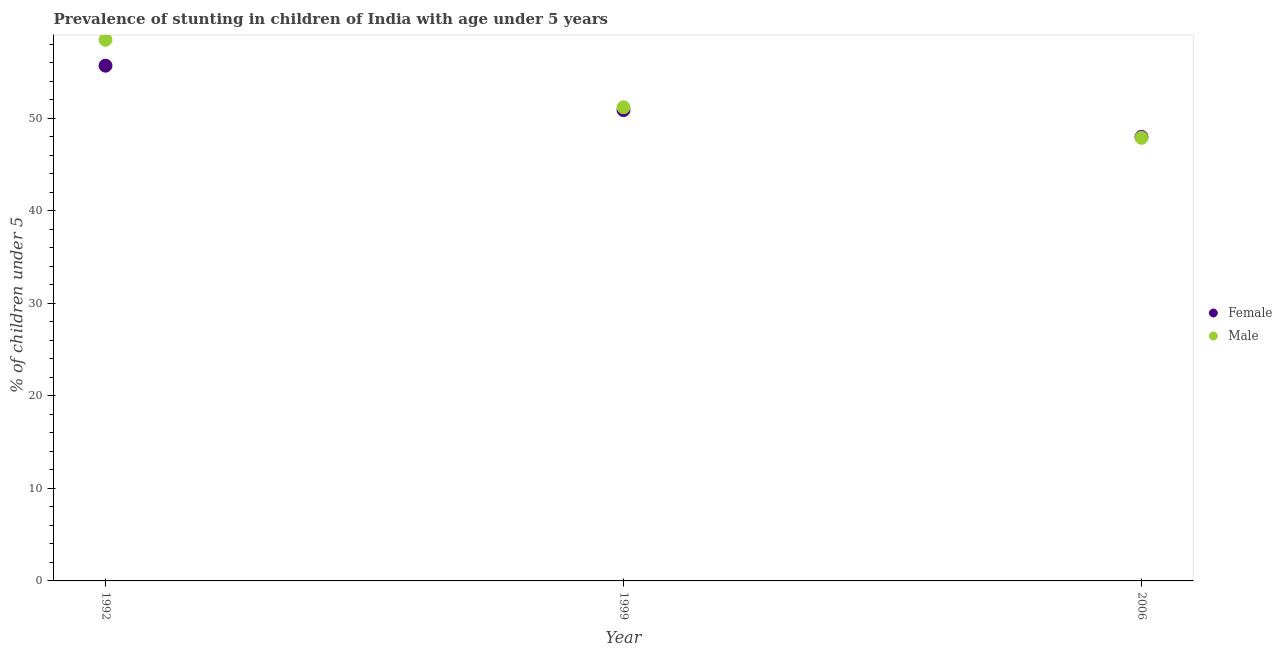Is the number of dotlines equal to the number of legend labels?
Your response must be concise. Yes. What is the percentage of stunted male children in 2006?
Your answer should be compact. 47.9. Across all years, what is the maximum percentage of stunted male children?
Ensure brevity in your answer.  58.5. What is the total percentage of stunted male children in the graph?
Provide a succinct answer. 157.6. What is the difference between the percentage of stunted female children in 1992 and that in 2006?
Your answer should be compact. 7.7. What is the difference between the percentage of stunted male children in 2006 and the percentage of stunted female children in 1999?
Ensure brevity in your answer.  -3. What is the average percentage of stunted male children per year?
Provide a short and direct response. 52.53. In the year 1999, what is the difference between the percentage of stunted female children and percentage of stunted male children?
Your answer should be very brief. -0.3. What is the ratio of the percentage of stunted male children in 1992 to that in 1999?
Ensure brevity in your answer.  1.14. Is the percentage of stunted female children in 1999 less than that in 2006?
Your response must be concise. No. What is the difference between the highest and the second highest percentage of stunted male children?
Make the answer very short. 7.3. What is the difference between the highest and the lowest percentage of stunted female children?
Offer a very short reply. 7.7. In how many years, is the percentage of stunted female children greater than the average percentage of stunted female children taken over all years?
Your answer should be very brief. 1. Does the percentage of stunted female children monotonically increase over the years?
Offer a very short reply. No. Is the percentage of stunted female children strictly less than the percentage of stunted male children over the years?
Provide a succinct answer. No. Does the graph contain any zero values?
Your response must be concise. No. Does the graph contain grids?
Your answer should be very brief. No. How are the legend labels stacked?
Provide a succinct answer. Vertical. What is the title of the graph?
Your answer should be compact. Prevalence of stunting in children of India with age under 5 years. Does "GDP" appear as one of the legend labels in the graph?
Give a very brief answer. No. What is the label or title of the Y-axis?
Your answer should be compact.  % of children under 5. What is the  % of children under 5 in Female in 1992?
Give a very brief answer. 55.7. What is the  % of children under 5 in Male in 1992?
Give a very brief answer. 58.5. What is the  % of children under 5 of Female in 1999?
Keep it short and to the point. 50.9. What is the  % of children under 5 in Male in 1999?
Your response must be concise. 51.2. What is the  % of children under 5 of Male in 2006?
Your response must be concise. 47.9. Across all years, what is the maximum  % of children under 5 in Female?
Your answer should be compact. 55.7. Across all years, what is the maximum  % of children under 5 in Male?
Your response must be concise. 58.5. Across all years, what is the minimum  % of children under 5 of Female?
Keep it short and to the point. 48. Across all years, what is the minimum  % of children under 5 of Male?
Your response must be concise. 47.9. What is the total  % of children under 5 in Female in the graph?
Your answer should be very brief. 154.6. What is the total  % of children under 5 in Male in the graph?
Make the answer very short. 157.6. What is the difference between the  % of children under 5 of Female in 1999 and the  % of children under 5 of Male in 2006?
Your answer should be very brief. 3. What is the average  % of children under 5 of Female per year?
Offer a very short reply. 51.53. What is the average  % of children under 5 of Male per year?
Offer a very short reply. 52.53. In the year 1992, what is the difference between the  % of children under 5 in Female and  % of children under 5 in Male?
Your answer should be compact. -2.8. What is the ratio of the  % of children under 5 of Female in 1992 to that in 1999?
Give a very brief answer. 1.09. What is the ratio of the  % of children under 5 of Male in 1992 to that in 1999?
Give a very brief answer. 1.14. What is the ratio of the  % of children under 5 in Female in 1992 to that in 2006?
Provide a succinct answer. 1.16. What is the ratio of the  % of children under 5 in Male in 1992 to that in 2006?
Provide a succinct answer. 1.22. What is the ratio of the  % of children under 5 of Female in 1999 to that in 2006?
Make the answer very short. 1.06. What is the ratio of the  % of children under 5 of Male in 1999 to that in 2006?
Provide a short and direct response. 1.07. What is the difference between the highest and the second highest  % of children under 5 in Female?
Make the answer very short. 4.8. What is the difference between the highest and the lowest  % of children under 5 of Female?
Give a very brief answer. 7.7. What is the difference between the highest and the lowest  % of children under 5 of Male?
Your answer should be compact. 10.6. 